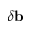<formula> <loc_0><loc_0><loc_500><loc_500>\delta b</formula> 